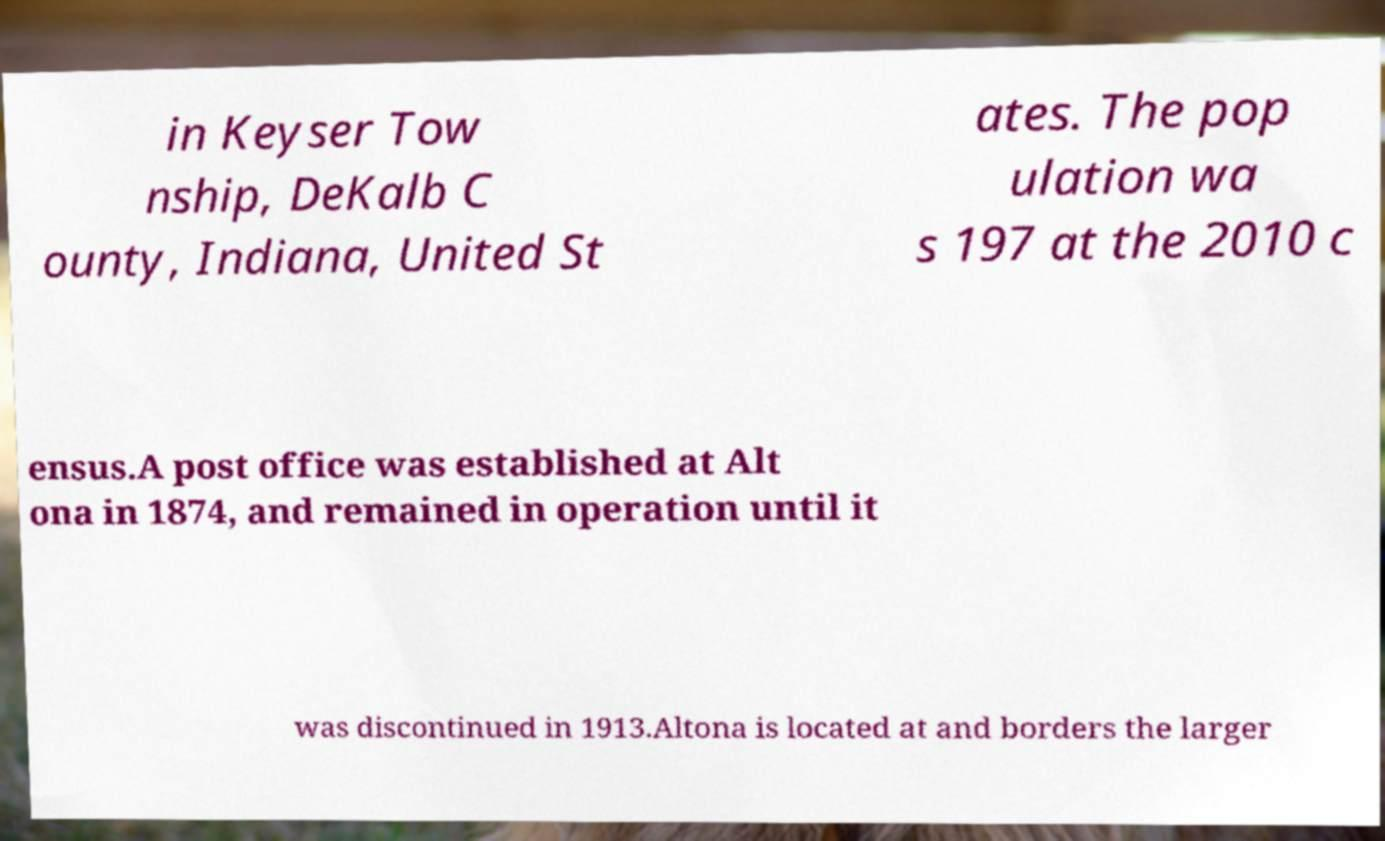Can you accurately transcribe the text from the provided image for me? in Keyser Tow nship, DeKalb C ounty, Indiana, United St ates. The pop ulation wa s 197 at the 2010 c ensus.A post office was established at Alt ona in 1874, and remained in operation until it was discontinued in 1913.Altona is located at and borders the larger 